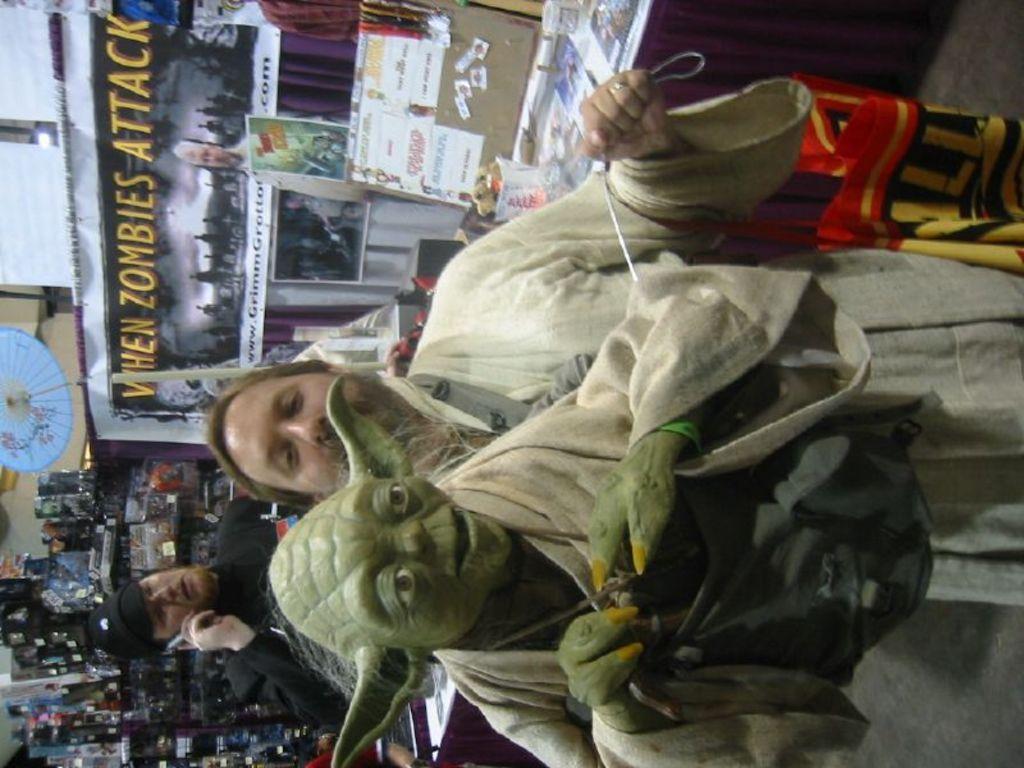Describe this image in one or two sentences. In this picture I can see there is a man standing and he is holding a toy, it is in front of him and there is another person standing in the backdrop and he is speaking and holding a mobile phone. There are few a posters, papers and objects in the backdrop. 